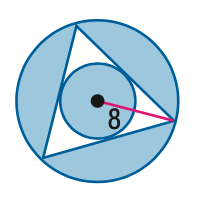Question: Find the area of the shaded region. Assume that all polygons that appear to be regular are regular. Round to the nearest tenth.
Choices:
A. 85.1
B. 168.2
C. 203.3
D. 268.7
Answer with the letter. Answer: B 